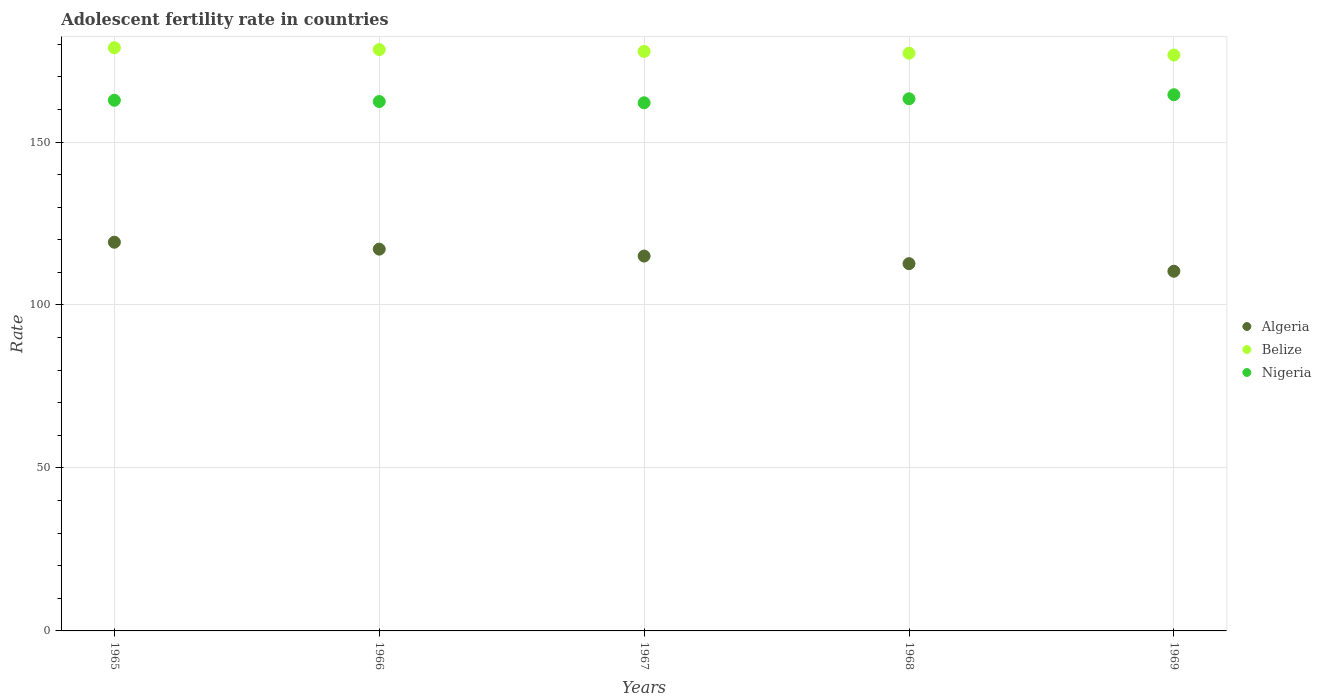How many different coloured dotlines are there?
Offer a terse response. 3. What is the adolescent fertility rate in Belize in 1969?
Give a very brief answer. 176.68. Across all years, what is the maximum adolescent fertility rate in Algeria?
Provide a succinct answer. 119.26. Across all years, what is the minimum adolescent fertility rate in Belize?
Ensure brevity in your answer.  176.68. In which year was the adolescent fertility rate in Algeria maximum?
Your answer should be compact. 1965. In which year was the adolescent fertility rate in Nigeria minimum?
Provide a succinct answer. 1967. What is the total adolescent fertility rate in Belize in the graph?
Make the answer very short. 889. What is the difference between the adolescent fertility rate in Algeria in 1967 and that in 1968?
Your response must be concise. 2.33. What is the difference between the adolescent fertility rate in Belize in 1968 and the adolescent fertility rate in Algeria in 1965?
Offer a very short reply. 57.98. What is the average adolescent fertility rate in Nigeria per year?
Your response must be concise. 163.01. In the year 1968, what is the difference between the adolescent fertility rate in Belize and adolescent fertility rate in Algeria?
Make the answer very short. 64.56. In how many years, is the adolescent fertility rate in Belize greater than 80?
Give a very brief answer. 5. What is the ratio of the adolescent fertility rate in Belize in 1965 to that in 1968?
Your answer should be very brief. 1.01. What is the difference between the highest and the second highest adolescent fertility rate in Nigeria?
Ensure brevity in your answer.  1.23. What is the difference between the highest and the lowest adolescent fertility rate in Algeria?
Offer a terse response. 8.91. Is the sum of the adolescent fertility rate in Algeria in 1966 and 1968 greater than the maximum adolescent fertility rate in Belize across all years?
Keep it short and to the point. Yes. Is it the case that in every year, the sum of the adolescent fertility rate in Nigeria and adolescent fertility rate in Belize  is greater than the adolescent fertility rate in Algeria?
Your answer should be very brief. Yes. Is the adolescent fertility rate in Belize strictly greater than the adolescent fertility rate in Algeria over the years?
Offer a very short reply. Yes. Is the adolescent fertility rate in Algeria strictly less than the adolescent fertility rate in Nigeria over the years?
Your answer should be compact. Yes. How many dotlines are there?
Your answer should be very brief. 3. Where does the legend appear in the graph?
Provide a succinct answer. Center right. How many legend labels are there?
Provide a succinct answer. 3. How are the legend labels stacked?
Provide a short and direct response. Vertical. What is the title of the graph?
Give a very brief answer. Adolescent fertility rate in countries. What is the label or title of the X-axis?
Offer a terse response. Years. What is the label or title of the Y-axis?
Ensure brevity in your answer.  Rate. What is the Rate of Algeria in 1965?
Your response must be concise. 119.26. What is the Rate in Belize in 1965?
Make the answer very short. 178.92. What is the Rate of Nigeria in 1965?
Provide a short and direct response. 162.8. What is the Rate of Algeria in 1966?
Make the answer very short. 117.13. What is the Rate of Belize in 1966?
Your answer should be compact. 178.36. What is the Rate of Nigeria in 1966?
Give a very brief answer. 162.42. What is the Rate in Algeria in 1967?
Ensure brevity in your answer.  115.01. What is the Rate of Belize in 1967?
Ensure brevity in your answer.  177.8. What is the Rate of Nigeria in 1967?
Ensure brevity in your answer.  162.04. What is the Rate of Algeria in 1968?
Provide a succinct answer. 112.68. What is the Rate in Belize in 1968?
Give a very brief answer. 177.24. What is the Rate in Nigeria in 1968?
Your answer should be compact. 163.27. What is the Rate of Algeria in 1969?
Provide a short and direct response. 110.35. What is the Rate of Belize in 1969?
Provide a succinct answer. 176.68. What is the Rate in Nigeria in 1969?
Ensure brevity in your answer.  164.51. Across all years, what is the maximum Rate in Algeria?
Your answer should be very brief. 119.26. Across all years, what is the maximum Rate of Belize?
Keep it short and to the point. 178.92. Across all years, what is the maximum Rate of Nigeria?
Offer a very short reply. 164.51. Across all years, what is the minimum Rate in Algeria?
Keep it short and to the point. 110.35. Across all years, what is the minimum Rate in Belize?
Make the answer very short. 176.68. Across all years, what is the minimum Rate in Nigeria?
Give a very brief answer. 162.04. What is the total Rate of Algeria in the graph?
Your answer should be compact. 574.44. What is the total Rate of Belize in the graph?
Keep it short and to the point. 889. What is the total Rate in Nigeria in the graph?
Provide a short and direct response. 815.04. What is the difference between the Rate in Algeria in 1965 and that in 1966?
Your response must be concise. 2.12. What is the difference between the Rate in Belize in 1965 and that in 1966?
Your response must be concise. 0.56. What is the difference between the Rate in Nigeria in 1965 and that in 1966?
Your response must be concise. 0.38. What is the difference between the Rate of Algeria in 1965 and that in 1967?
Ensure brevity in your answer.  4.24. What is the difference between the Rate of Belize in 1965 and that in 1967?
Offer a very short reply. 1.12. What is the difference between the Rate of Nigeria in 1965 and that in 1967?
Your answer should be very brief. 0.77. What is the difference between the Rate in Algeria in 1965 and that in 1968?
Your answer should be compact. 6.58. What is the difference between the Rate in Belize in 1965 and that in 1968?
Keep it short and to the point. 1.68. What is the difference between the Rate of Nigeria in 1965 and that in 1968?
Your answer should be compact. -0.47. What is the difference between the Rate of Algeria in 1965 and that in 1969?
Offer a very short reply. 8.91. What is the difference between the Rate of Belize in 1965 and that in 1969?
Offer a very short reply. 2.24. What is the difference between the Rate of Nigeria in 1965 and that in 1969?
Offer a terse response. -1.7. What is the difference between the Rate of Algeria in 1966 and that in 1967?
Give a very brief answer. 2.12. What is the difference between the Rate of Belize in 1966 and that in 1967?
Make the answer very short. 0.56. What is the difference between the Rate of Nigeria in 1966 and that in 1967?
Your answer should be compact. 0.38. What is the difference between the Rate in Algeria in 1966 and that in 1968?
Provide a succinct answer. 4.45. What is the difference between the Rate of Belize in 1966 and that in 1968?
Offer a very short reply. 1.12. What is the difference between the Rate of Nigeria in 1966 and that in 1968?
Keep it short and to the point. -0.85. What is the difference between the Rate in Algeria in 1966 and that in 1969?
Offer a terse response. 6.78. What is the difference between the Rate in Belize in 1966 and that in 1969?
Offer a terse response. 1.68. What is the difference between the Rate of Nigeria in 1966 and that in 1969?
Give a very brief answer. -2.08. What is the difference between the Rate of Algeria in 1967 and that in 1968?
Ensure brevity in your answer.  2.33. What is the difference between the Rate in Belize in 1967 and that in 1968?
Ensure brevity in your answer.  0.56. What is the difference between the Rate of Nigeria in 1967 and that in 1968?
Keep it short and to the point. -1.23. What is the difference between the Rate in Algeria in 1967 and that in 1969?
Your response must be concise. 4.66. What is the difference between the Rate of Belize in 1967 and that in 1969?
Ensure brevity in your answer.  1.12. What is the difference between the Rate of Nigeria in 1967 and that in 1969?
Offer a very short reply. -2.47. What is the difference between the Rate in Algeria in 1968 and that in 1969?
Provide a short and direct response. 2.33. What is the difference between the Rate of Belize in 1968 and that in 1969?
Keep it short and to the point. 0.56. What is the difference between the Rate in Nigeria in 1968 and that in 1969?
Provide a succinct answer. -1.23. What is the difference between the Rate of Algeria in 1965 and the Rate of Belize in 1966?
Your answer should be very brief. -59.1. What is the difference between the Rate of Algeria in 1965 and the Rate of Nigeria in 1966?
Offer a very short reply. -43.16. What is the difference between the Rate in Belize in 1965 and the Rate in Nigeria in 1966?
Your answer should be compact. 16.5. What is the difference between the Rate in Algeria in 1965 and the Rate in Belize in 1967?
Offer a terse response. -58.54. What is the difference between the Rate in Algeria in 1965 and the Rate in Nigeria in 1967?
Your response must be concise. -42.78. What is the difference between the Rate in Belize in 1965 and the Rate in Nigeria in 1967?
Your answer should be very brief. 16.88. What is the difference between the Rate in Algeria in 1965 and the Rate in Belize in 1968?
Keep it short and to the point. -57.98. What is the difference between the Rate in Algeria in 1965 and the Rate in Nigeria in 1968?
Offer a very short reply. -44.01. What is the difference between the Rate of Belize in 1965 and the Rate of Nigeria in 1968?
Ensure brevity in your answer.  15.65. What is the difference between the Rate of Algeria in 1965 and the Rate of Belize in 1969?
Ensure brevity in your answer.  -57.42. What is the difference between the Rate of Algeria in 1965 and the Rate of Nigeria in 1969?
Your response must be concise. -45.25. What is the difference between the Rate in Belize in 1965 and the Rate in Nigeria in 1969?
Provide a succinct answer. 14.41. What is the difference between the Rate of Algeria in 1966 and the Rate of Belize in 1967?
Make the answer very short. -60.67. What is the difference between the Rate of Algeria in 1966 and the Rate of Nigeria in 1967?
Keep it short and to the point. -44.9. What is the difference between the Rate in Belize in 1966 and the Rate in Nigeria in 1967?
Keep it short and to the point. 16.32. What is the difference between the Rate of Algeria in 1966 and the Rate of Belize in 1968?
Offer a very short reply. -60.11. What is the difference between the Rate in Algeria in 1966 and the Rate in Nigeria in 1968?
Your response must be concise. -46.14. What is the difference between the Rate in Belize in 1966 and the Rate in Nigeria in 1968?
Keep it short and to the point. 15.09. What is the difference between the Rate of Algeria in 1966 and the Rate of Belize in 1969?
Your answer should be compact. -59.55. What is the difference between the Rate in Algeria in 1966 and the Rate in Nigeria in 1969?
Provide a short and direct response. -47.37. What is the difference between the Rate in Belize in 1966 and the Rate in Nigeria in 1969?
Offer a very short reply. 13.85. What is the difference between the Rate of Algeria in 1967 and the Rate of Belize in 1968?
Keep it short and to the point. -62.23. What is the difference between the Rate in Algeria in 1967 and the Rate in Nigeria in 1968?
Provide a succinct answer. -48.26. What is the difference between the Rate in Belize in 1967 and the Rate in Nigeria in 1968?
Your response must be concise. 14.53. What is the difference between the Rate of Algeria in 1967 and the Rate of Belize in 1969?
Your response must be concise. -61.67. What is the difference between the Rate of Algeria in 1967 and the Rate of Nigeria in 1969?
Ensure brevity in your answer.  -49.49. What is the difference between the Rate of Belize in 1967 and the Rate of Nigeria in 1969?
Offer a terse response. 13.29. What is the difference between the Rate in Algeria in 1968 and the Rate in Belize in 1969?
Provide a short and direct response. -64. What is the difference between the Rate in Algeria in 1968 and the Rate in Nigeria in 1969?
Your response must be concise. -51.82. What is the difference between the Rate of Belize in 1968 and the Rate of Nigeria in 1969?
Make the answer very short. 12.73. What is the average Rate in Algeria per year?
Keep it short and to the point. 114.89. What is the average Rate in Belize per year?
Keep it short and to the point. 177.8. What is the average Rate of Nigeria per year?
Your answer should be very brief. 163.01. In the year 1965, what is the difference between the Rate of Algeria and Rate of Belize?
Your response must be concise. -59.66. In the year 1965, what is the difference between the Rate in Algeria and Rate in Nigeria?
Your response must be concise. -43.55. In the year 1965, what is the difference between the Rate in Belize and Rate in Nigeria?
Give a very brief answer. 16.12. In the year 1966, what is the difference between the Rate in Algeria and Rate in Belize?
Your answer should be very brief. -61.23. In the year 1966, what is the difference between the Rate in Algeria and Rate in Nigeria?
Provide a succinct answer. -45.29. In the year 1966, what is the difference between the Rate of Belize and Rate of Nigeria?
Ensure brevity in your answer.  15.94. In the year 1967, what is the difference between the Rate in Algeria and Rate in Belize?
Make the answer very short. -62.79. In the year 1967, what is the difference between the Rate of Algeria and Rate of Nigeria?
Provide a succinct answer. -47.02. In the year 1967, what is the difference between the Rate of Belize and Rate of Nigeria?
Provide a succinct answer. 15.76. In the year 1968, what is the difference between the Rate of Algeria and Rate of Belize?
Provide a short and direct response. -64.56. In the year 1968, what is the difference between the Rate in Algeria and Rate in Nigeria?
Your answer should be very brief. -50.59. In the year 1968, what is the difference between the Rate in Belize and Rate in Nigeria?
Provide a short and direct response. 13.97. In the year 1969, what is the difference between the Rate in Algeria and Rate in Belize?
Provide a succinct answer. -66.33. In the year 1969, what is the difference between the Rate of Algeria and Rate of Nigeria?
Provide a succinct answer. -54.15. In the year 1969, what is the difference between the Rate in Belize and Rate in Nigeria?
Make the answer very short. 12.17. What is the ratio of the Rate of Algeria in 1965 to that in 1966?
Give a very brief answer. 1.02. What is the ratio of the Rate of Belize in 1965 to that in 1966?
Your answer should be compact. 1. What is the ratio of the Rate in Nigeria in 1965 to that in 1966?
Keep it short and to the point. 1. What is the ratio of the Rate of Algeria in 1965 to that in 1967?
Ensure brevity in your answer.  1.04. What is the ratio of the Rate in Algeria in 1965 to that in 1968?
Your answer should be compact. 1.06. What is the ratio of the Rate of Belize in 1965 to that in 1968?
Make the answer very short. 1.01. What is the ratio of the Rate of Nigeria in 1965 to that in 1968?
Your answer should be compact. 1. What is the ratio of the Rate in Algeria in 1965 to that in 1969?
Ensure brevity in your answer.  1.08. What is the ratio of the Rate in Belize in 1965 to that in 1969?
Your answer should be compact. 1.01. What is the ratio of the Rate in Algeria in 1966 to that in 1967?
Offer a very short reply. 1.02. What is the ratio of the Rate in Belize in 1966 to that in 1967?
Make the answer very short. 1. What is the ratio of the Rate of Nigeria in 1966 to that in 1967?
Offer a terse response. 1. What is the ratio of the Rate in Algeria in 1966 to that in 1968?
Make the answer very short. 1.04. What is the ratio of the Rate of Nigeria in 1966 to that in 1968?
Keep it short and to the point. 0.99. What is the ratio of the Rate of Algeria in 1966 to that in 1969?
Your answer should be very brief. 1.06. What is the ratio of the Rate of Belize in 1966 to that in 1969?
Offer a very short reply. 1.01. What is the ratio of the Rate in Nigeria in 1966 to that in 1969?
Ensure brevity in your answer.  0.99. What is the ratio of the Rate of Algeria in 1967 to that in 1968?
Give a very brief answer. 1.02. What is the ratio of the Rate of Nigeria in 1967 to that in 1968?
Your answer should be compact. 0.99. What is the ratio of the Rate in Algeria in 1967 to that in 1969?
Give a very brief answer. 1.04. What is the ratio of the Rate in Algeria in 1968 to that in 1969?
Your answer should be compact. 1.02. What is the ratio of the Rate in Nigeria in 1968 to that in 1969?
Make the answer very short. 0.99. What is the difference between the highest and the second highest Rate in Algeria?
Give a very brief answer. 2.12. What is the difference between the highest and the second highest Rate of Belize?
Offer a very short reply. 0.56. What is the difference between the highest and the second highest Rate in Nigeria?
Your answer should be very brief. 1.23. What is the difference between the highest and the lowest Rate of Algeria?
Your answer should be compact. 8.91. What is the difference between the highest and the lowest Rate of Belize?
Make the answer very short. 2.24. What is the difference between the highest and the lowest Rate in Nigeria?
Your answer should be compact. 2.47. 